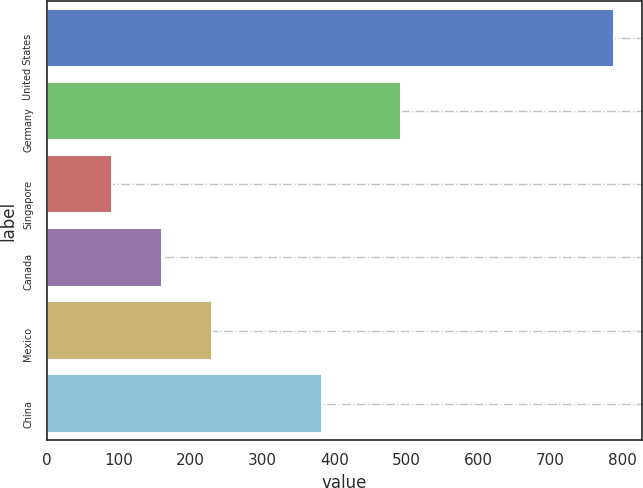Convert chart. <chart><loc_0><loc_0><loc_500><loc_500><bar_chart><fcel>United States<fcel>Germany<fcel>Singapore<fcel>Canada<fcel>Mexico<fcel>China<nl><fcel>788<fcel>493<fcel>91<fcel>160.7<fcel>230.4<fcel>383<nl></chart> 